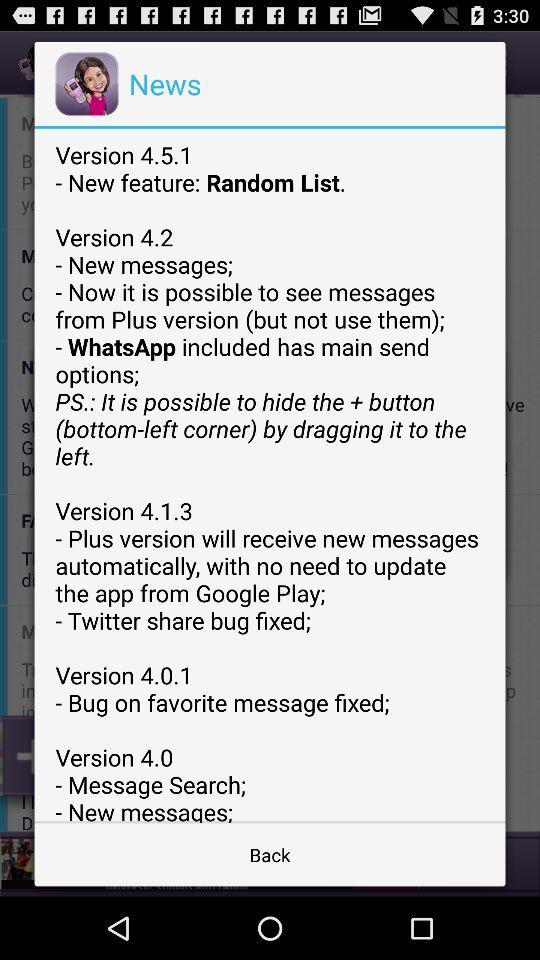What changes were made in version 4.0? The changes made in version 4.0 were "Message Search" and "New messages". 